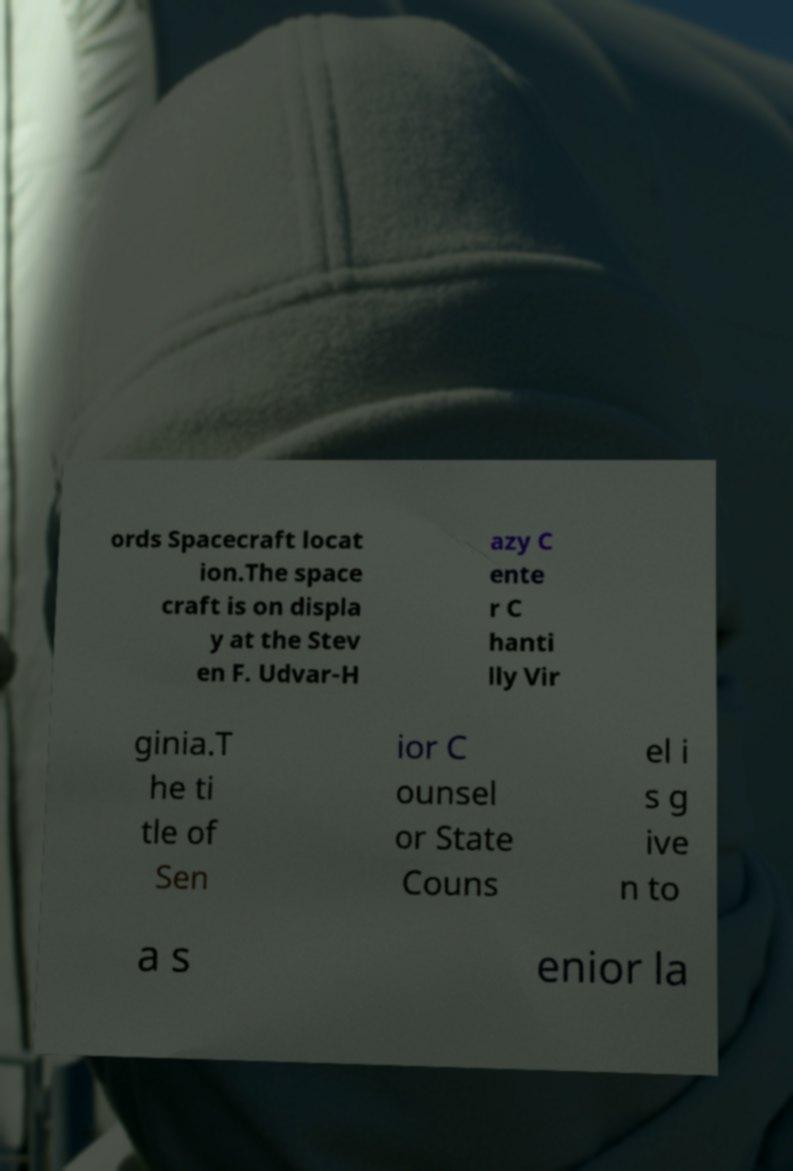Please read and relay the text visible in this image. What does it say? ords Spacecraft locat ion.The space craft is on displa y at the Stev en F. Udvar-H azy C ente r C hanti lly Vir ginia.T he ti tle of Sen ior C ounsel or State Couns el i s g ive n to a s enior la 